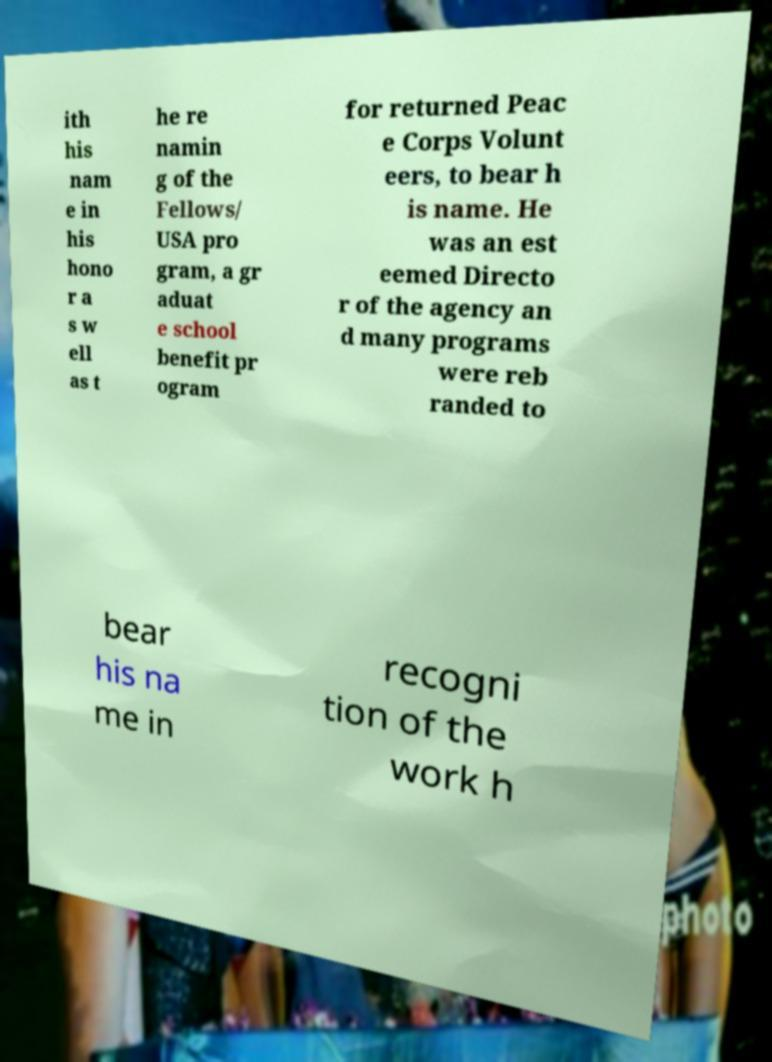Can you read and provide the text displayed in the image?This photo seems to have some interesting text. Can you extract and type it out for me? ith his nam e in his hono r a s w ell as t he re namin g of the Fellows/ USA pro gram, a gr aduat e school benefit pr ogram for returned Peac e Corps Volunt eers, to bear h is name. He was an est eemed Directo r of the agency an d many programs were reb randed to bear his na me in recogni tion of the work h 